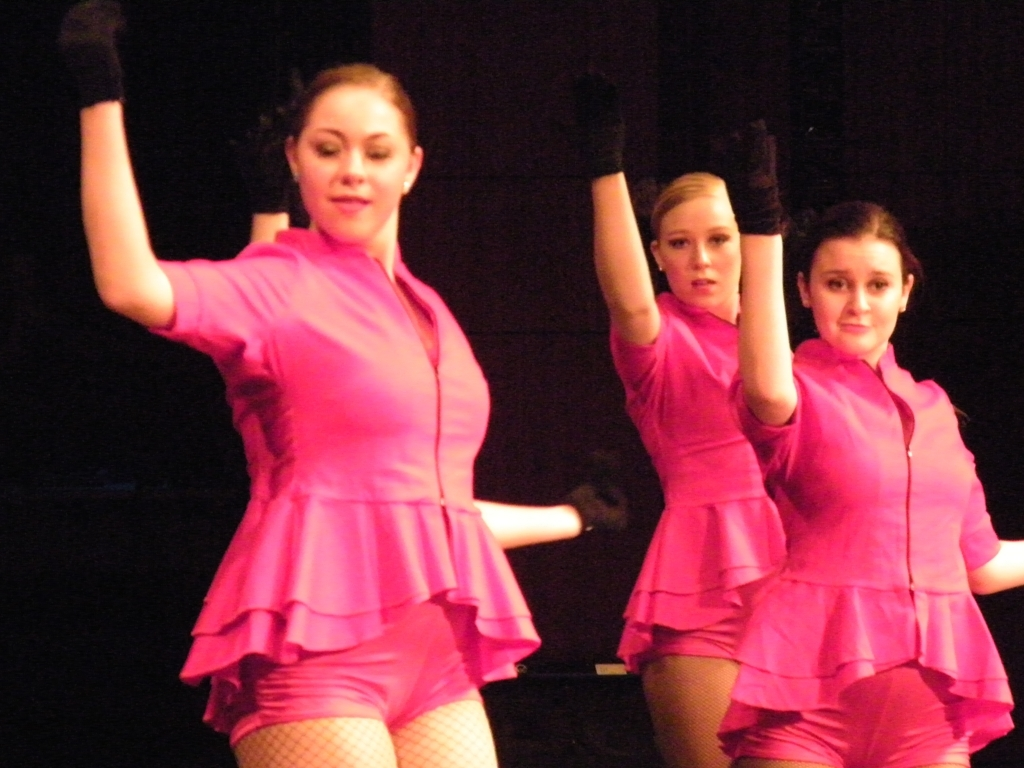Could you describe their outfits? The dancers are wearing bright pink, short-sleeved dresses with a ruffled skirt, black gloves, and fishnet tights. Their attire is eye-catching and complements the energy of their performance. Do their outfits serve a purpose for the dance they're performing? Yes, their outfits are designed not only to be visually appealing but also to allow for a full range of movement, which is essential for the fluid motions of jazz dance. The vibrant color also helps in capturing and holding the audience's attention. 